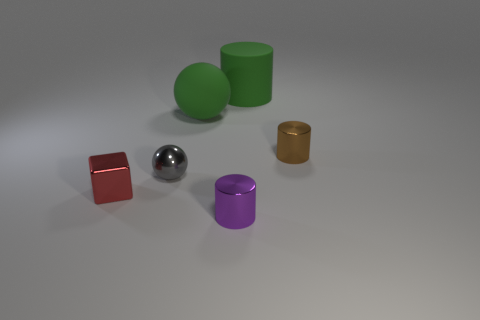Subtract all tiny metallic cylinders. How many cylinders are left? 1 Subtract all green cylinders. How many cylinders are left? 2 Add 3 big matte cylinders. How many objects exist? 9 Subtract 1 spheres. How many spheres are left? 1 Subtract all red cylinders. How many yellow spheres are left? 0 Subtract 0 gray cylinders. How many objects are left? 6 Subtract all cubes. How many objects are left? 5 Subtract all cyan spheres. Subtract all yellow blocks. How many spheres are left? 2 Subtract all brown things. Subtract all small shiny cubes. How many objects are left? 4 Add 4 small brown things. How many small brown things are left? 5 